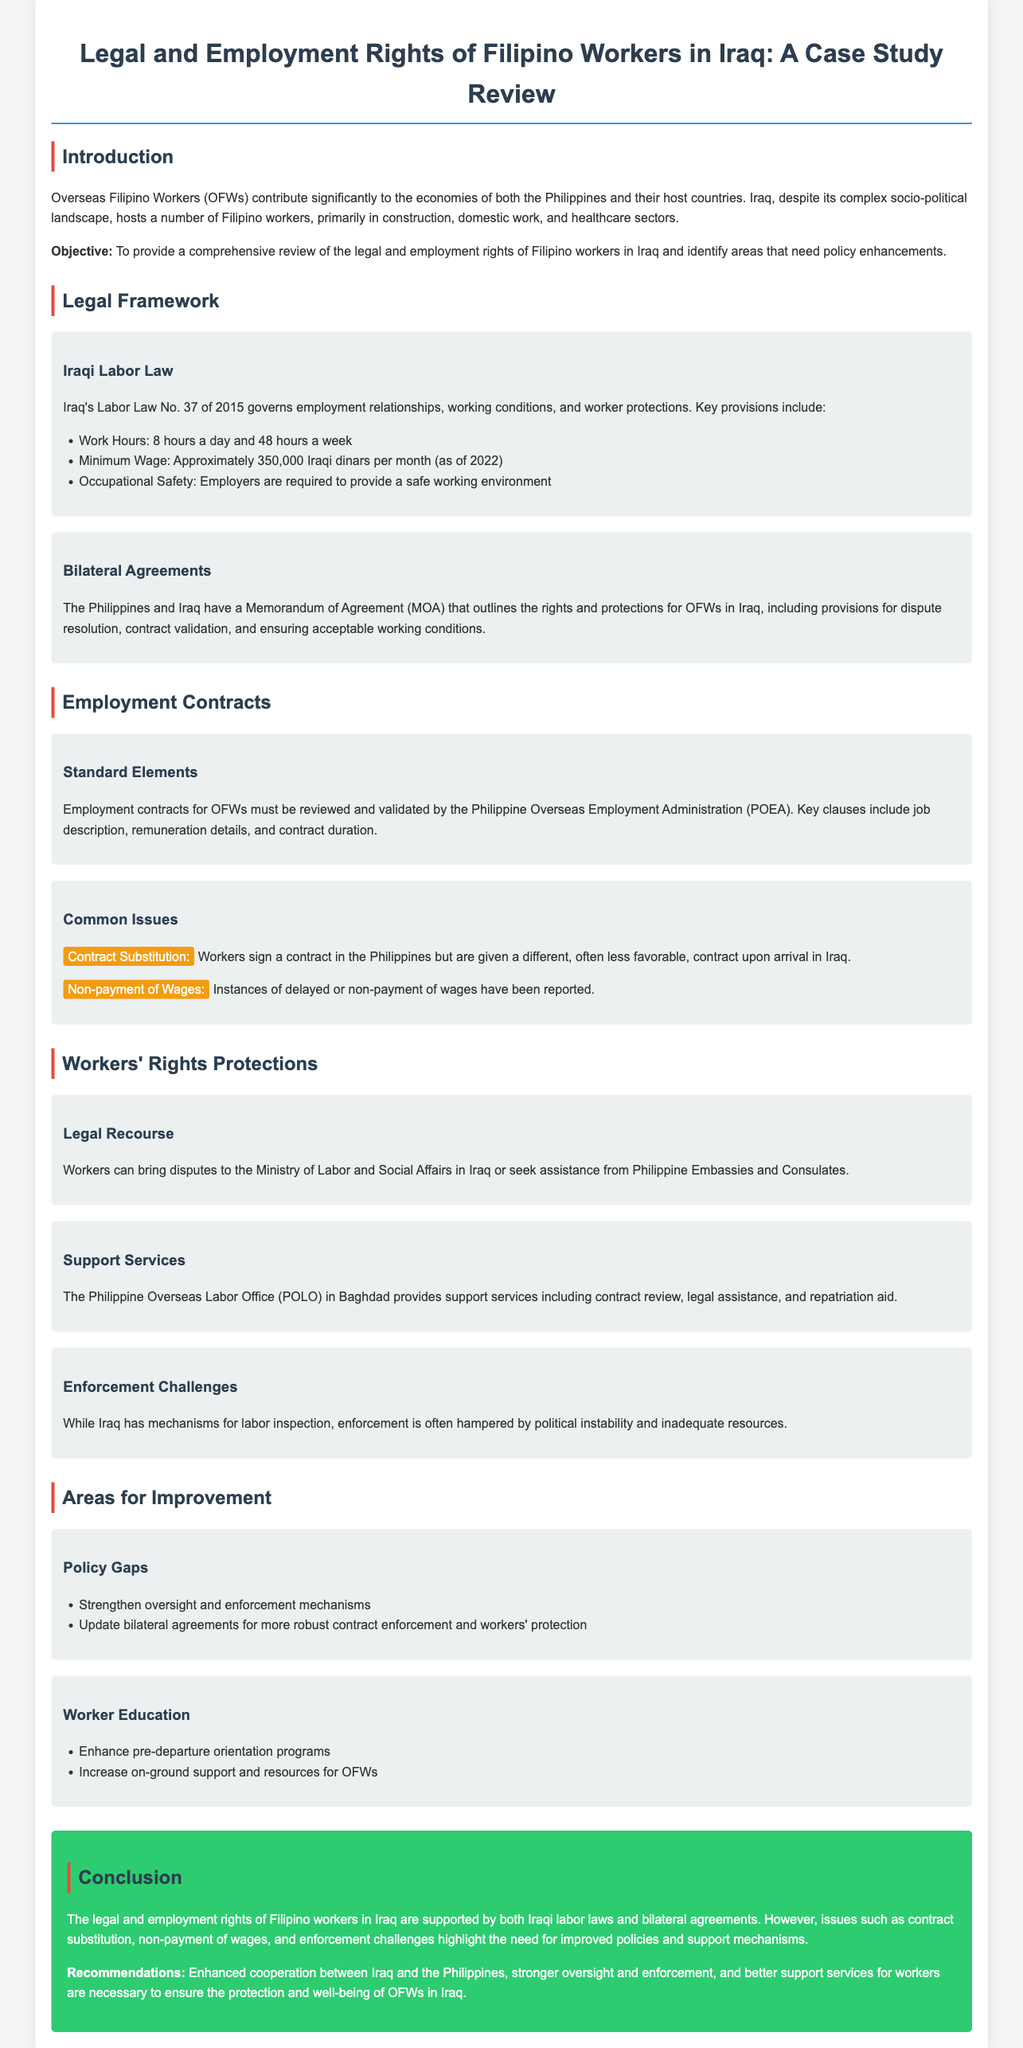What law governs employment relationships in Iraq? Iraqi Labor Law No. 37 of 2015 governs employment relationships, working conditions, and worker protections.
Answer: Iraqi Labor Law No. 37 of 2015 What is the maximum work hours per week according to Iraqi Labor Law? The document states that the law specifies a maximum of 48 hours per week for workers.
Answer: 48 hours What is a common issue faced by OFWs in terms of contracts? The text highlights that contract substitution is a prevalent issue where workers receive less favorable contracts upon arrival.
Answer: Contract Substitution Which Philippine agency validates employment contracts for OFWs? The document specifies that the Philippine Overseas Employment Administration (POEA) is responsible for the validation of contracts.
Answer: Philippine Overseas Employment Administration (POEA) What support is provided by the Philippine Overseas Labor Office in Baghdad? The document explains that the POLO provides legal assistance, contract review, and repatriation aid among other services.
Answer: Legal assistance, contract review, and repatriation aid What is identified as a gap needing policy improvement for OFWs? The document mentions that strengthening oversight and enforcement mechanisms is crucial for better worker protection.
Answer: Strengthen oversight and enforcement mechanisms Which sector employs many Filipino workers in Iraq? The introduction highlights that Filipino workers are primarily employed in construction, domestic work, and healthcare sectors.
Answer: Construction, domestic work, and healthcare What issue complicates the enforcement of labor laws in Iraq? The document notes that political instability and inadequate resources hamper the enforcement of labor laws.
Answer: Political instability and inadequate resources What is the minimum wage in Iraq as of 2022? The document states that the minimum wage is approximately 350,000 Iraqi dinars per month as of 2022.
Answer: 350,000 Iraqi dinars 